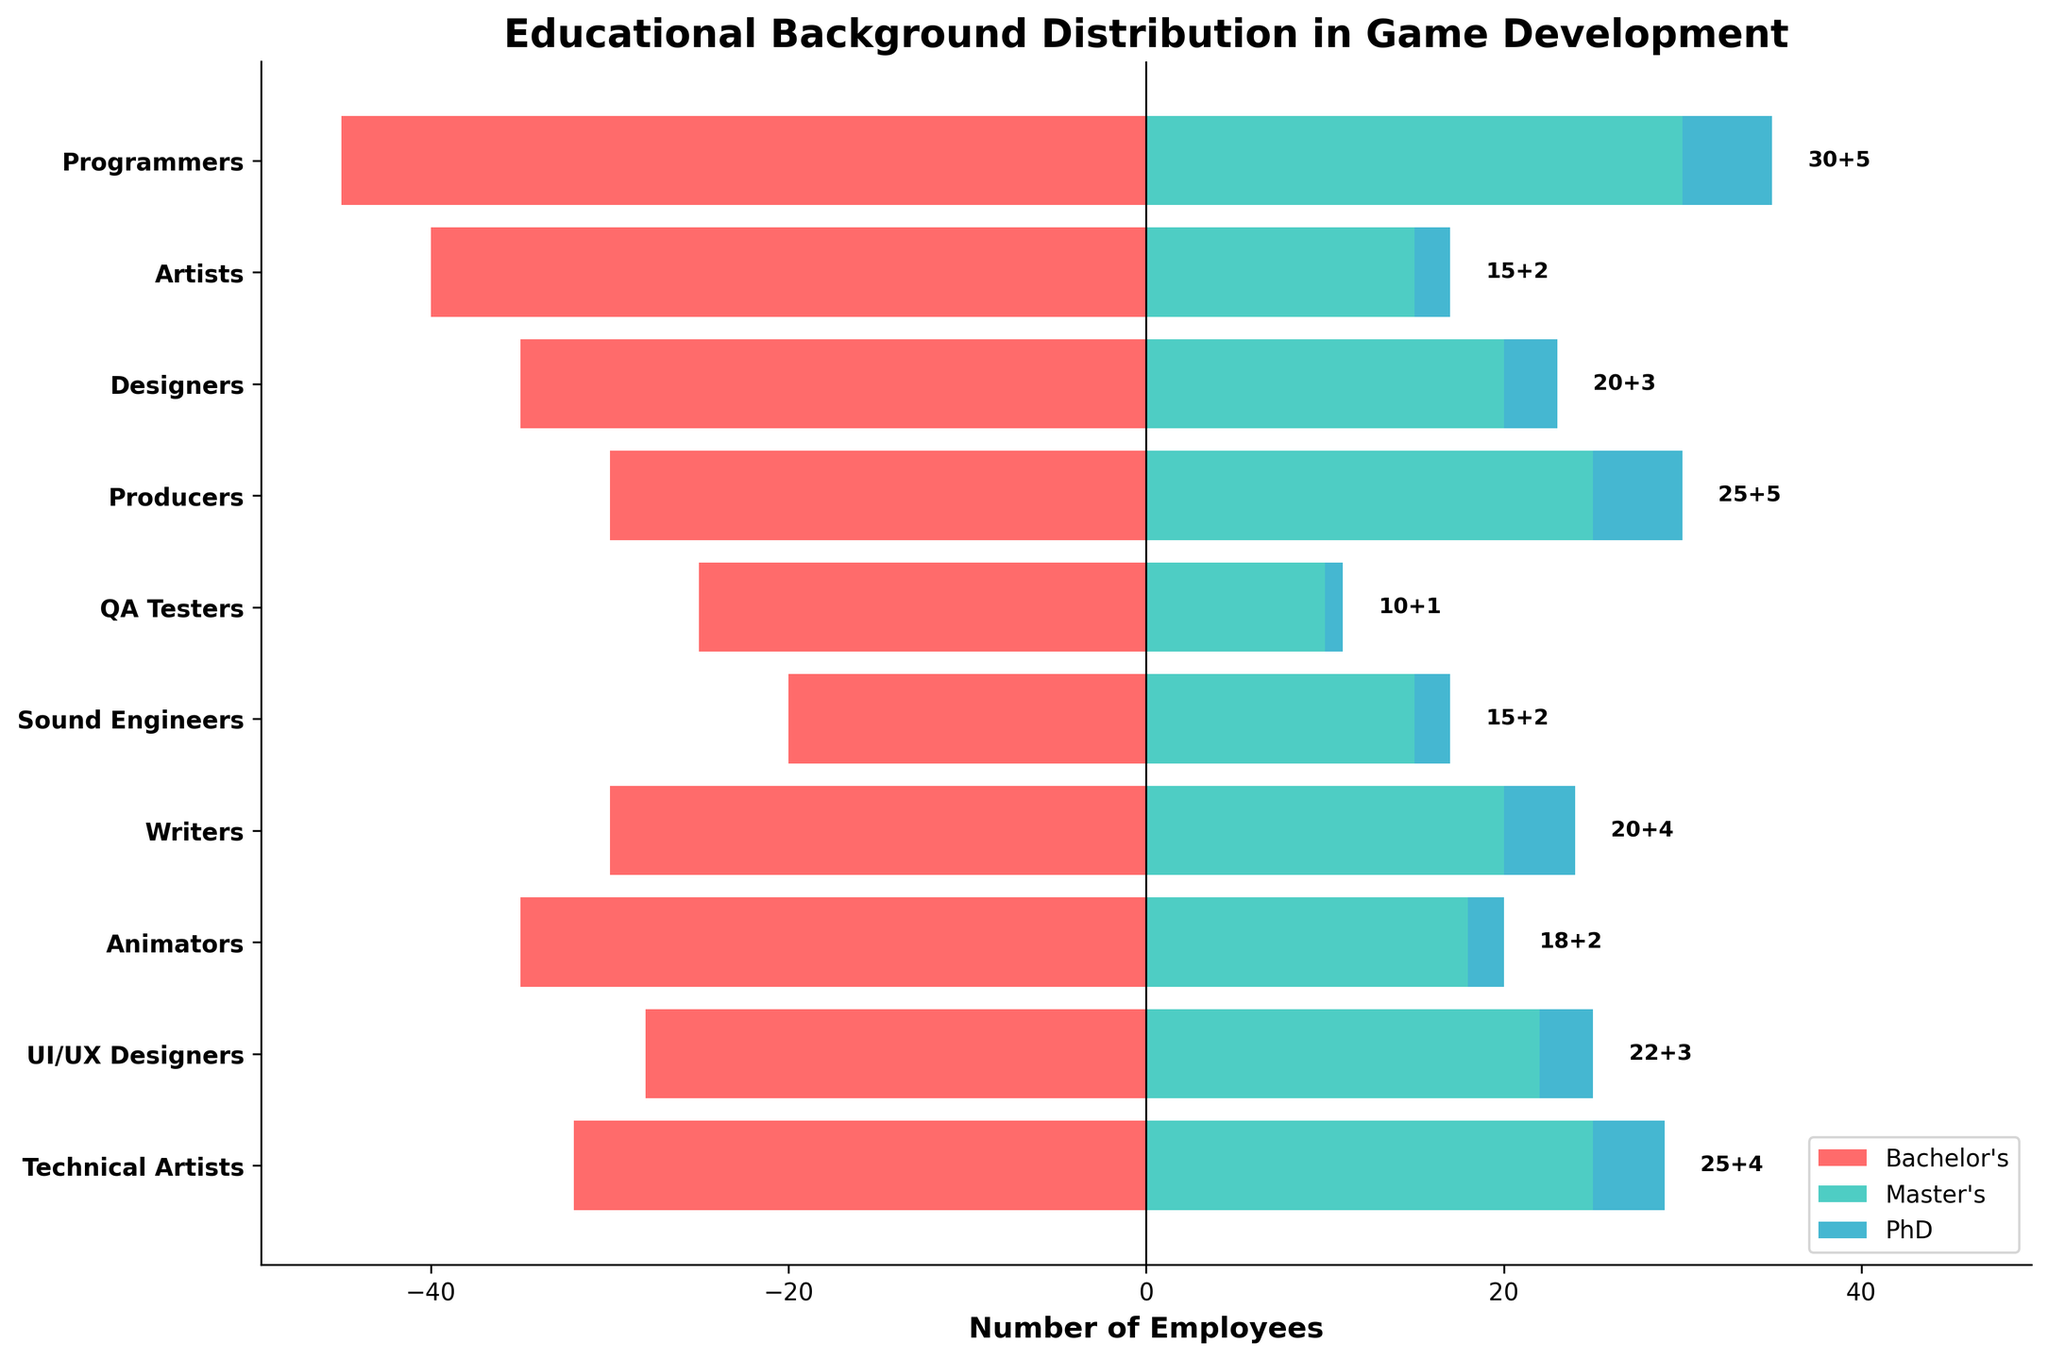What is the title of the figure? The title of the figure is displayed prominently at the top. It reads 'Educational Background Distribution in Game Development'.
Answer: Educational Background Distribution in Game Development Which role has the highest number of employees with a Bachelor's degree? By observing the lengths of the red bars, we can see that programmers have the highest number of employees with a Bachelor's degree.
Answer: Programmers What are the total counts of Master's and PhD degrees for UI/UX Designers combined? For UI/UX Designers, the green bar represents Master's degrees (22), and the blue bar represents PhD degrees (3). Adding these together gives 25.
Answer: 25 Which two roles have an equal number of employees with a PhD degree? Observing the figure, both Artists and Animators have a blue bar representing a PhD degree count of 2.
Answer: Artists, Animators Do any roles have a Master's degree count equal to the number of employees with a Bachelor's degree in Sound Engineers? By looking at the green bars for all roles and the red bar for Sound Engineers, we see that Master's counts for Producers (25) equal the Bachelor's count for Sound Engineers (20).
Answer: No How does the number of Bachelor's degrees for QA Testers compare to that of Writers? Comparing the lengths of the red bars, QA Testers have 25 and Writers have 30 Bachelor's degrees. Thus, Writers have more Bachelor's degrees.
Answer: Writers have more What is the sum of Bachelor's and Master's degrees for Programmers? The Bachelor's degree count for Programmers is 45, and the Master's degree count is 30. Adding these together gives a sum of 75.
Answer: 75 Which role has the smallest number of employees with any advanced degree (Master's or PhD)? Comparing the lengths of the green and blue bars, Sound Engineers and QA Testers have the lowest total, but QA Testers have the lowest with a sum of 11 (10 Master's + 1 PhD).
Answer: QA Testers Is the number of employees with Doctorates (PhDs) greater than 5 for any role? Observing the lengths of the blue bars, no role has a PhD count greater than 5. The maximum is exactly 5 for Programmers and Producers.
Answer: No Which role has the highest combined total of Bachelor's, Master's, and PhD degrees? Summing up the counts of Bachelor's, Master's, and PhD degrees for each role, Programmers have the highest total: 45 (Bachelor's) + 30 (Master's) + 5 (PhD) = 80.
Answer: Programmers 